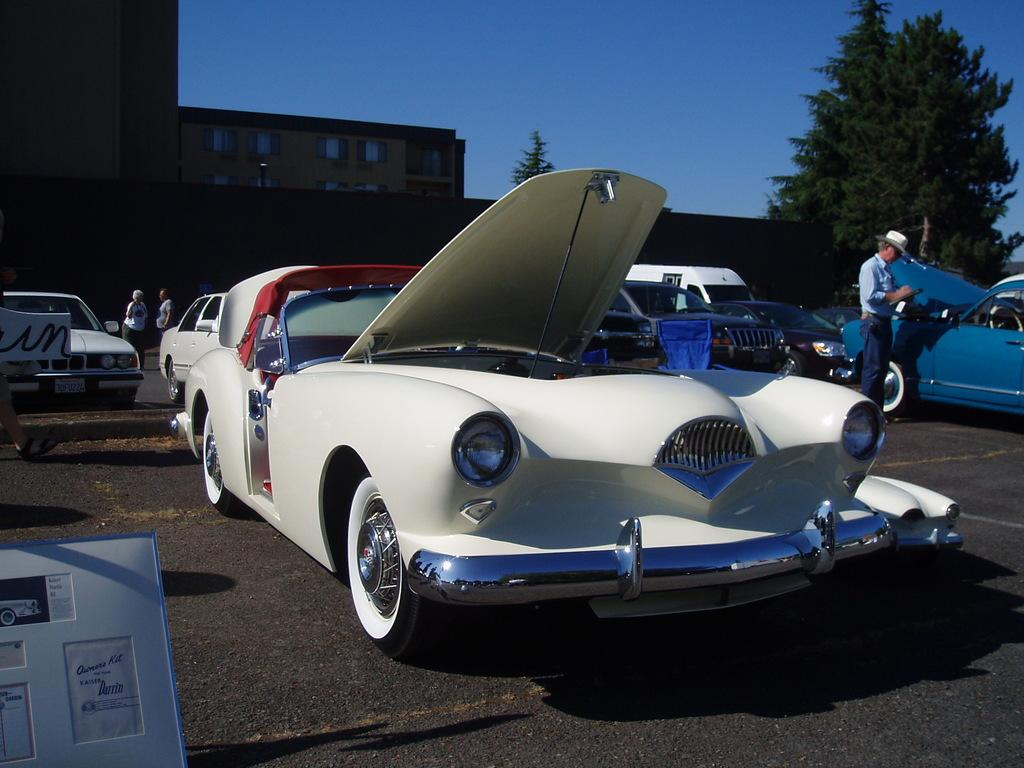What color are the cars in the image? The cars in the image are white. What else can be seen in the image besides the cars? There are people, buildings, trees, and the sky visible in the image. Can you describe the lighting in the image? The image appears to be slightly dark. Where is the market located in the image? There is no market present in the image. Can you tell me how many people are stuck in the quicksand in the image? There is no quicksand present in the image. 